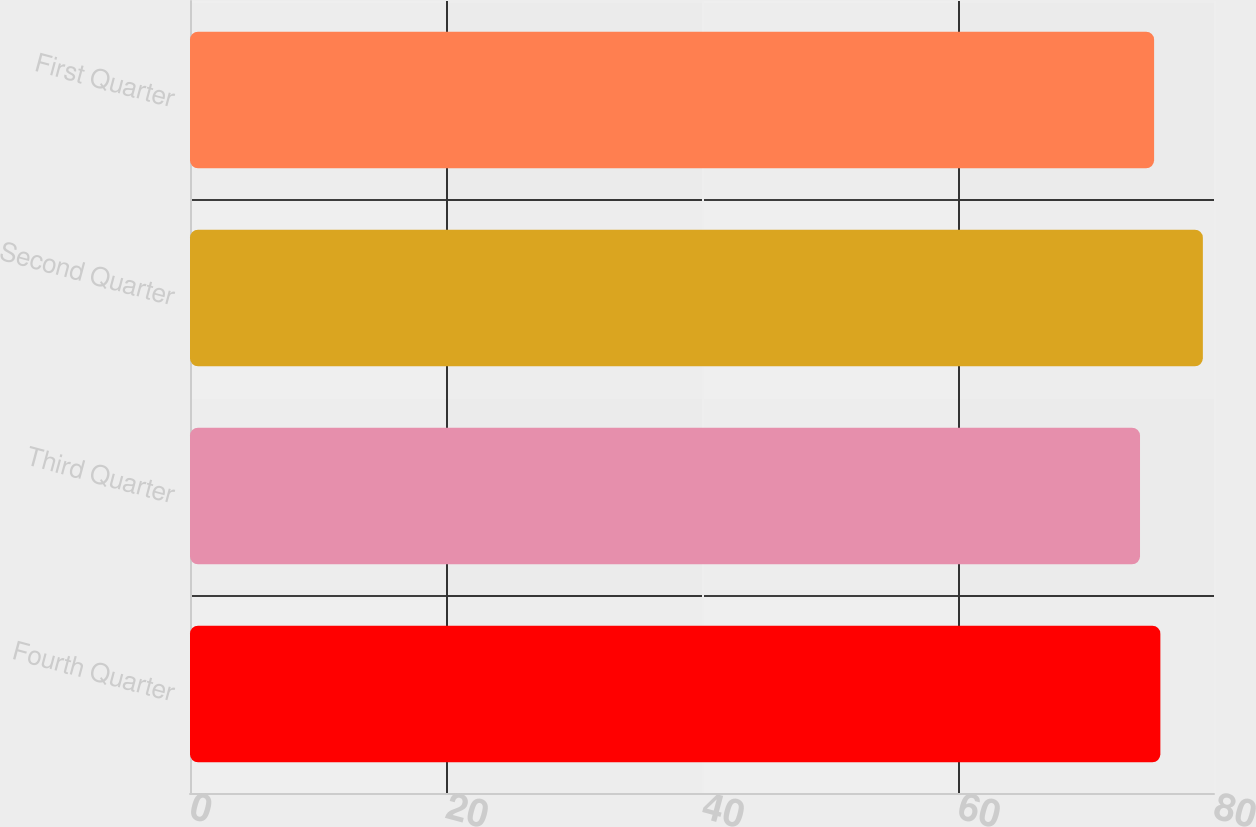Convert chart to OTSL. <chart><loc_0><loc_0><loc_500><loc_500><bar_chart><fcel>Fourth Quarter<fcel>Third Quarter<fcel>Second Quarter<fcel>First Quarter<nl><fcel>75.81<fcel>74.22<fcel>79.13<fcel>75.32<nl></chart> 